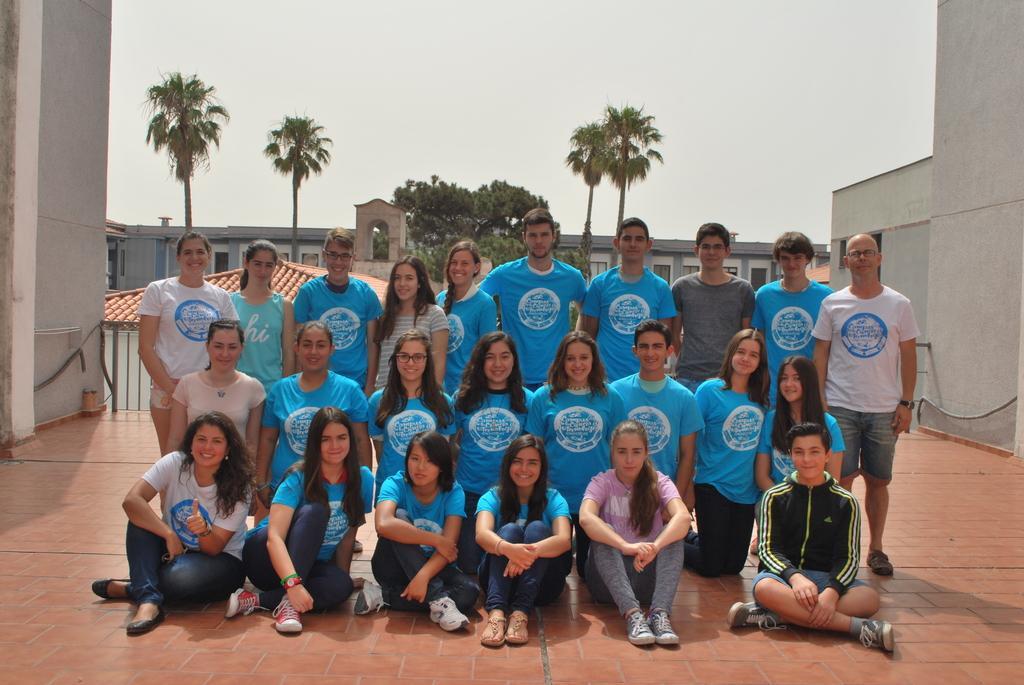In one or two sentences, can you explain what this image depicts? In the image there is a group of people. Few of them are wearing blue t-shirts, and few of them are wearing white t-shirt and some are with different color t-shirts. At the back of them there are trees and buildings with walls and windows. On the left and right side of the image there are walls. At the top of the image there is a sky. 